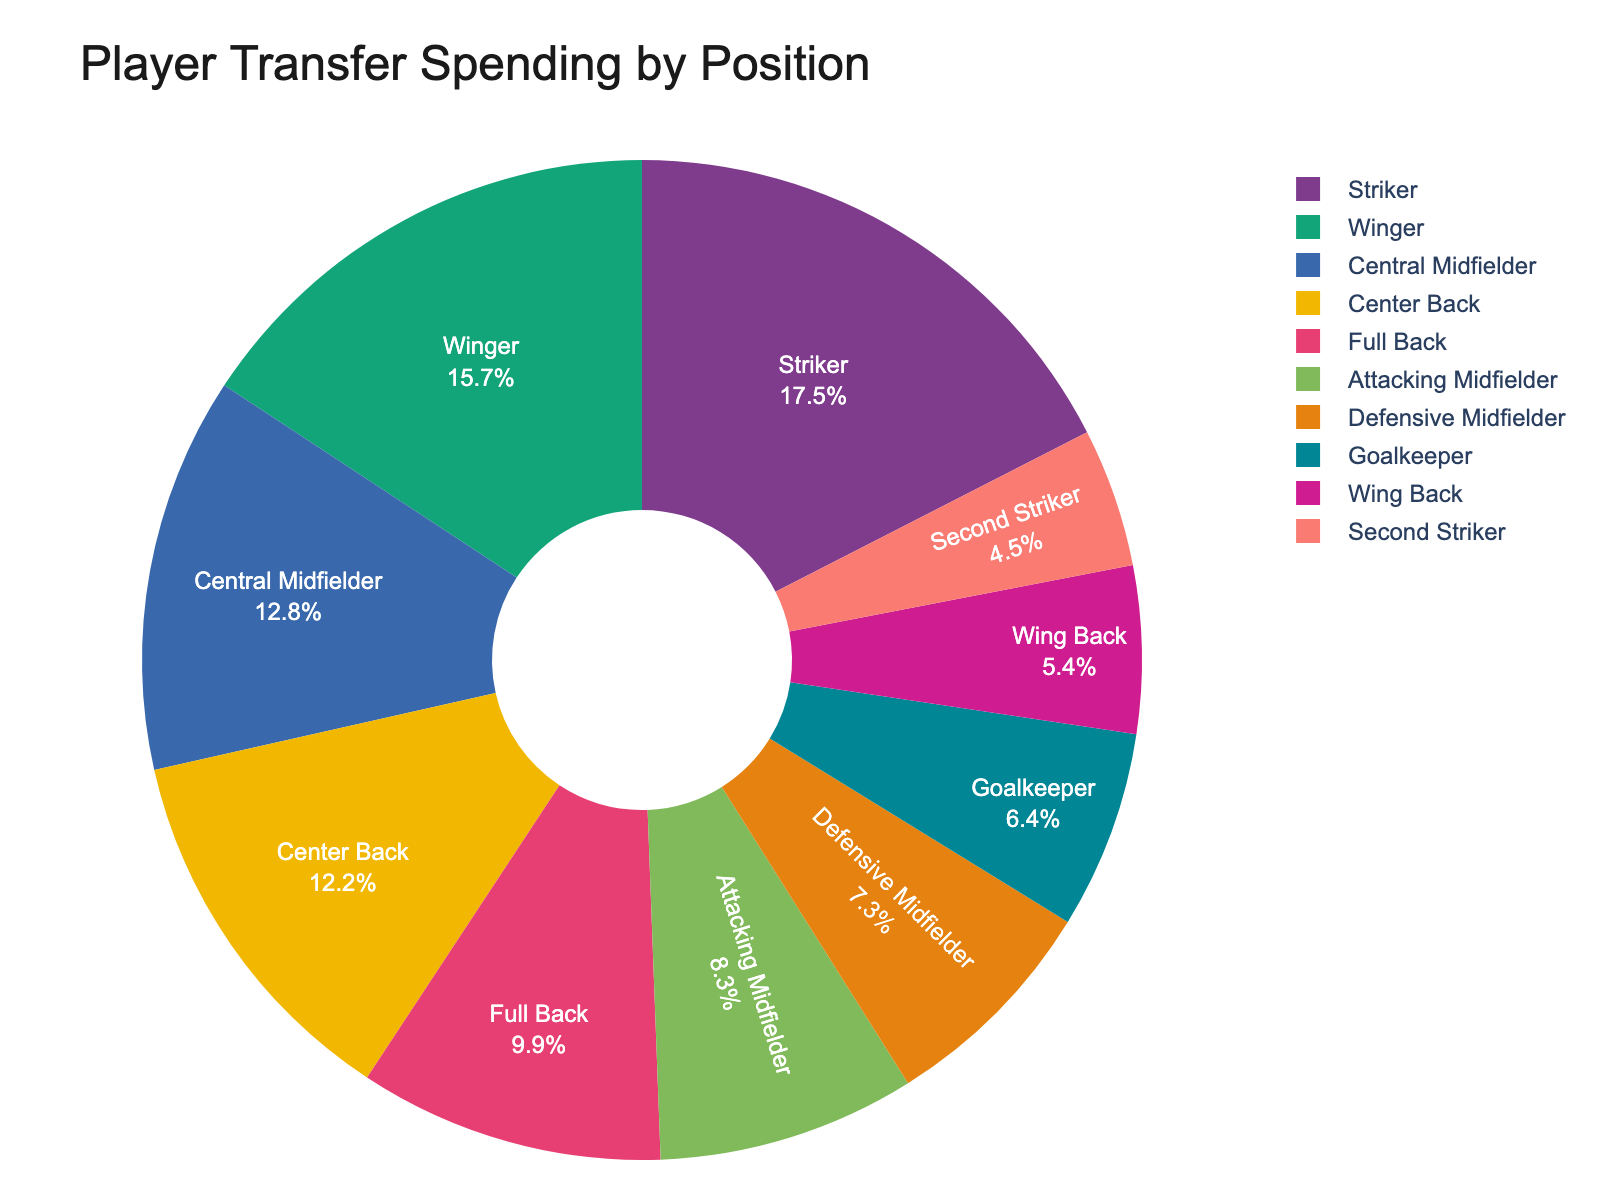What percentage of the total transfer spending do Central Midfielders account for? To find the percentage of the total transfer spending for Central Midfielders, locate the corresponding slice on the pie chart. The percentage is usually labeled directly inside the segment or visually represented through its size.
Answer: Around 18% Which position had the highest transfer spending? The position with the highest transfer spending will have the largest slice and the highest percentage on the pie chart.
Answer: Striker How much more was spent on Wingers compared to Goalkeepers? Find the spending amounts for both Wingers (385.2 million €) and Goalkeepers (156.7 million €). Subtract the two values to get the difference: 385.2 - 156.7 = 228.5 million €.
Answer: 228.5 million € What's the combined transfer spending for defensive positions (Center Back, Full Back, Wing Back)? Locate each defensive position's spending (Center Back: 298.6, Full Back: 241.3, Wing Back: 132.5 millions €) and add them up: 298.6 + 241.3 + 132.5 = 672.4 million €.
Answer: 672.4 million € Are there any positions with almost equal transfer spending? To determine if any two positions have almost equal spending, visually compare the sizes of the pie chart segments. The 'Attacking Midfielder' (203.9 million €) and 'Defensive Midfielder' (178.4 million €) segments are close in size.
Answer: Yes, Attacking Midfielder and Defensive Midfielder Which position has spent less than 10% of the total transfer spending? Identify the positions that have smaller slices on the pie chart, read their percentages, and check if they are less than 10%. 'Wing Back' has the smallest percentage slice, observed to be less than 10%.
Answer: Wing Back What is the transfer spending for positions in the midfield (Central Midfielder, Attacking Midfielder, Defensive Midfielder)? Sum the spending for the midfield positions (Central Midfielder: 312.8, Attacking Midfielder: 203.9, Defensive Midfielder: 178.4 millions €): 312.8 + 203.9 + 178.4 = 695.1 million €.
Answer: 695.1 million € What's the difference in spending between the position with the highest and the lowest transfer spending? Identify the maximum and minimum spending amounts: Highest (Striker: 427.5 million €) and Lowest (Second Striker: 109.8 million €). Subtract the two values: 427.5 - 109.8 = 317.7 million €.
Answer: 317.7 million € Is the transfer spending on Center Backs more than 20% of the total? Locate the percentage label for Center Backs on the pie chart and compare if it's greater than 20%.
Answer: No 